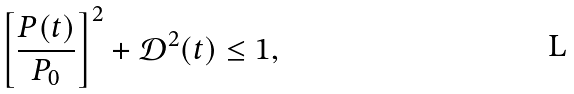<formula> <loc_0><loc_0><loc_500><loc_500>\left [ \frac { P ( t ) } { P _ { 0 } } \right ] ^ { 2 } + \mathcal { D } ^ { 2 } ( t ) \leq 1 ,</formula> 